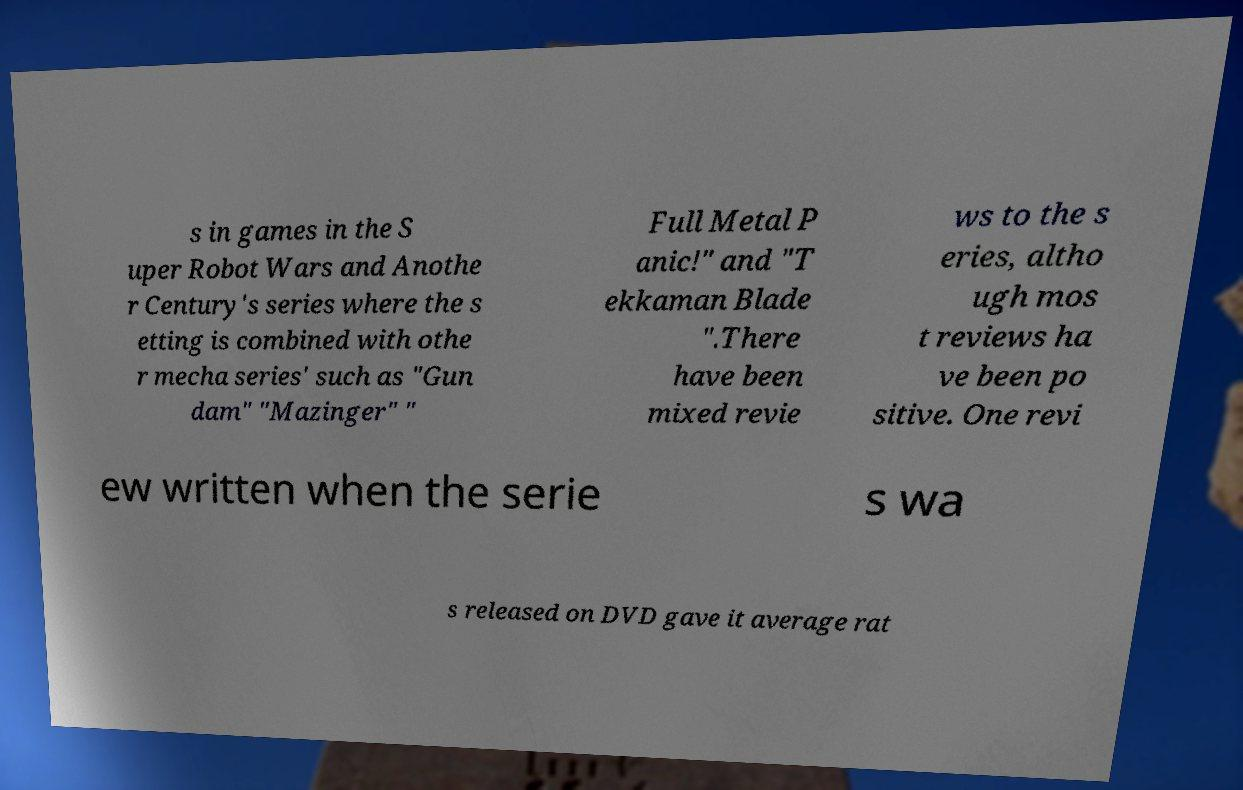Can you read and provide the text displayed in the image?This photo seems to have some interesting text. Can you extract and type it out for me? s in games in the S uper Robot Wars and Anothe r Century's series where the s etting is combined with othe r mecha series' such as "Gun dam" "Mazinger" " Full Metal P anic!" and "T ekkaman Blade ".There have been mixed revie ws to the s eries, altho ugh mos t reviews ha ve been po sitive. One revi ew written when the serie s wa s released on DVD gave it average rat 